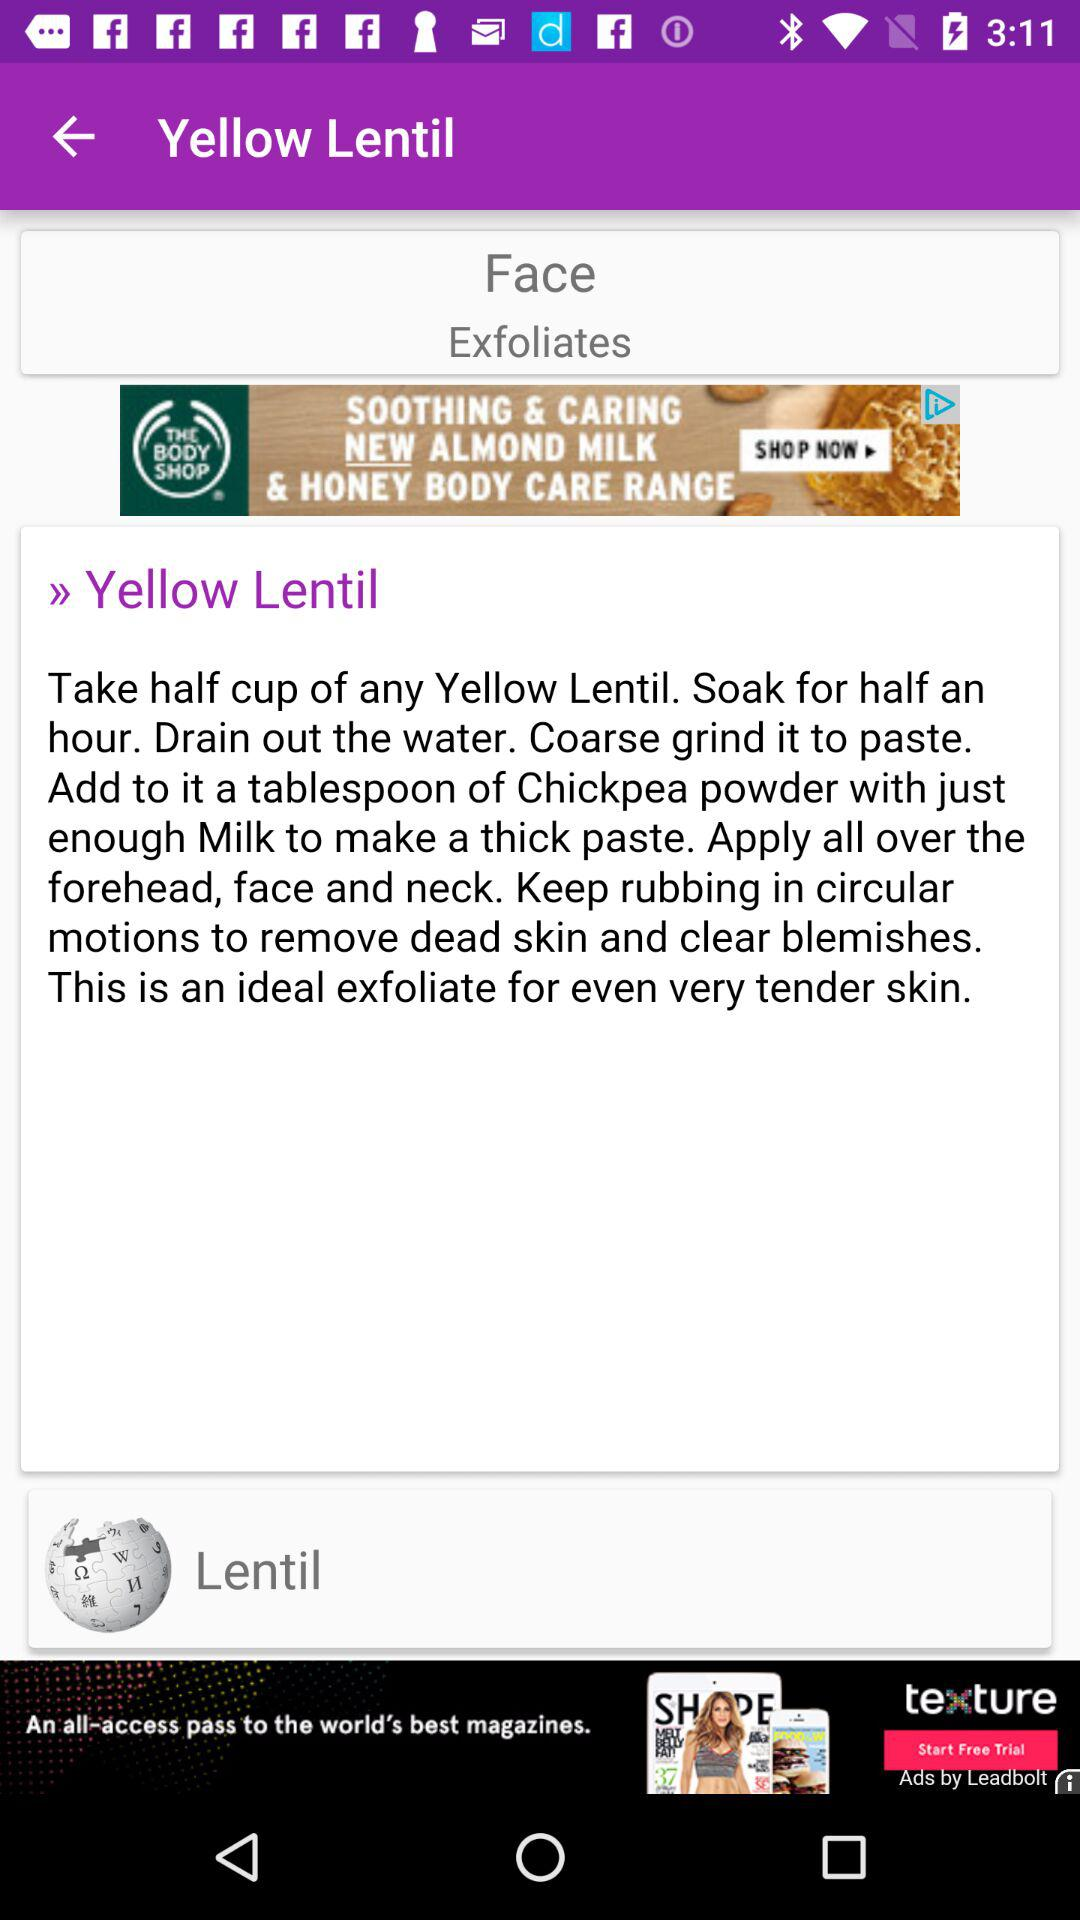How much chickpea powder is added? The amount of chickpea powder added is one tablespoon. 